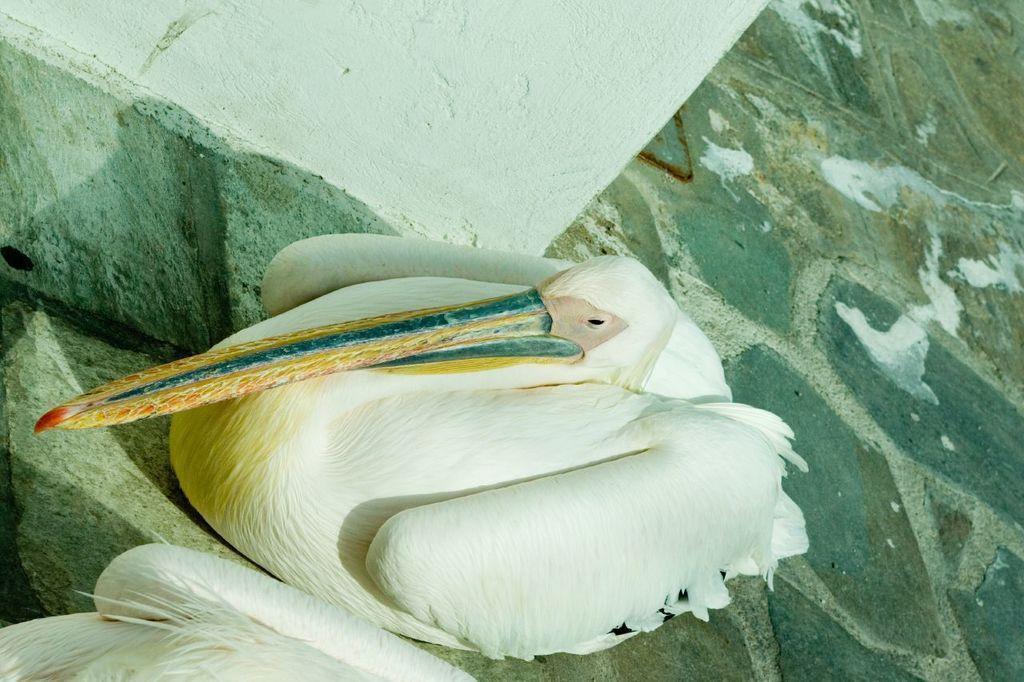In one or two sentences, can you explain what this image depicts? In this image, we can see a white bird with long beak sitting on the path. At the top of the image, there is a white wall. In the bottom left corner, there is another bird. 